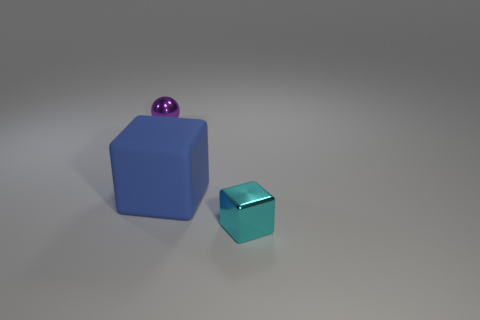Add 2 metal things. How many objects exist? 5 Subtract all cubes. How many objects are left? 1 Add 2 tiny shiny objects. How many tiny shiny objects exist? 4 Subtract 0 red spheres. How many objects are left? 3 Subtract all large blue objects. Subtract all brown blocks. How many objects are left? 2 Add 2 large things. How many large things are left? 3 